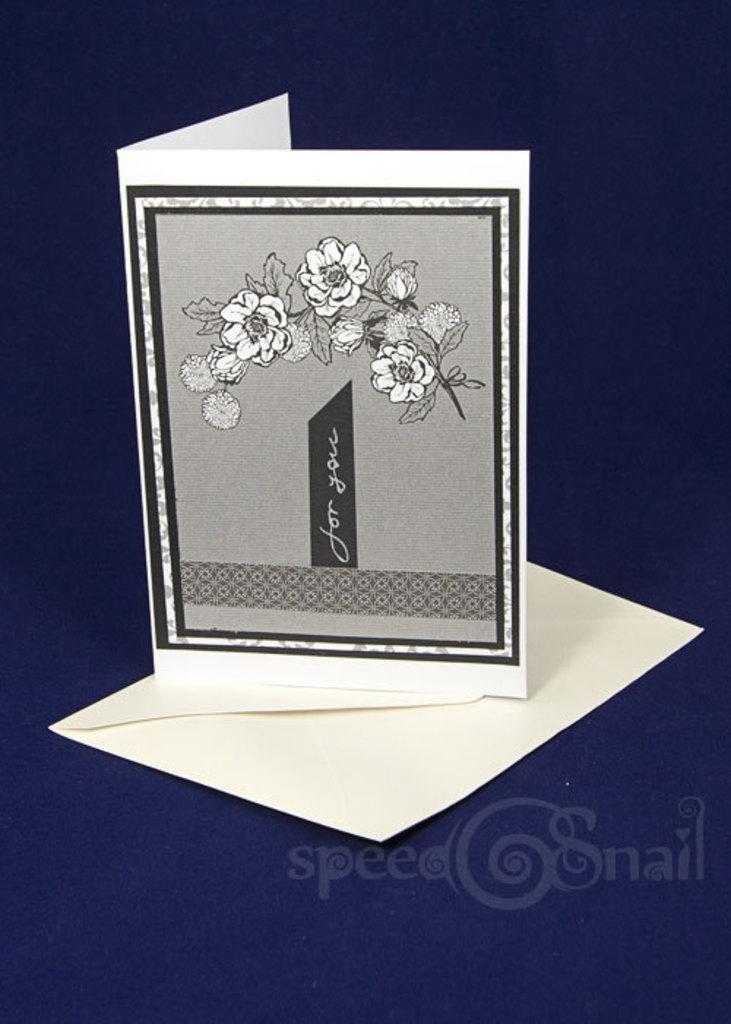Can you describe this image briefly? In this image I can see the greeting card which is in black, white and ash in color. I can see an envelope on the blue color surface. I can also see the name speed snail is written on the blue color surface. 